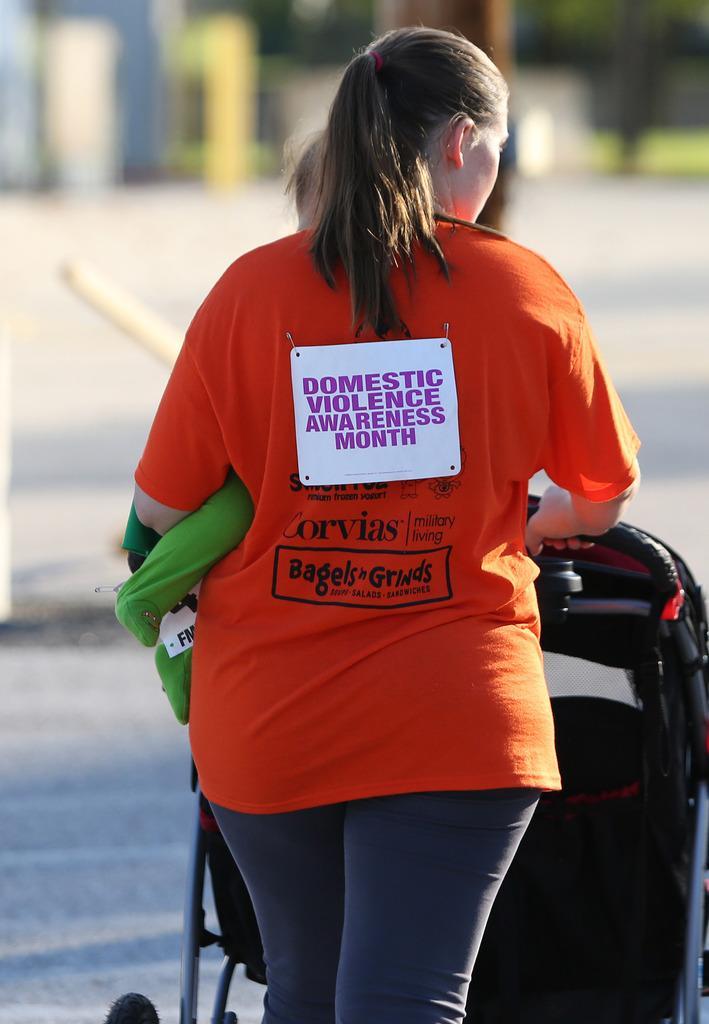Please provide a concise description of this image. In the center of the image there is a woman and trolley on the road. 